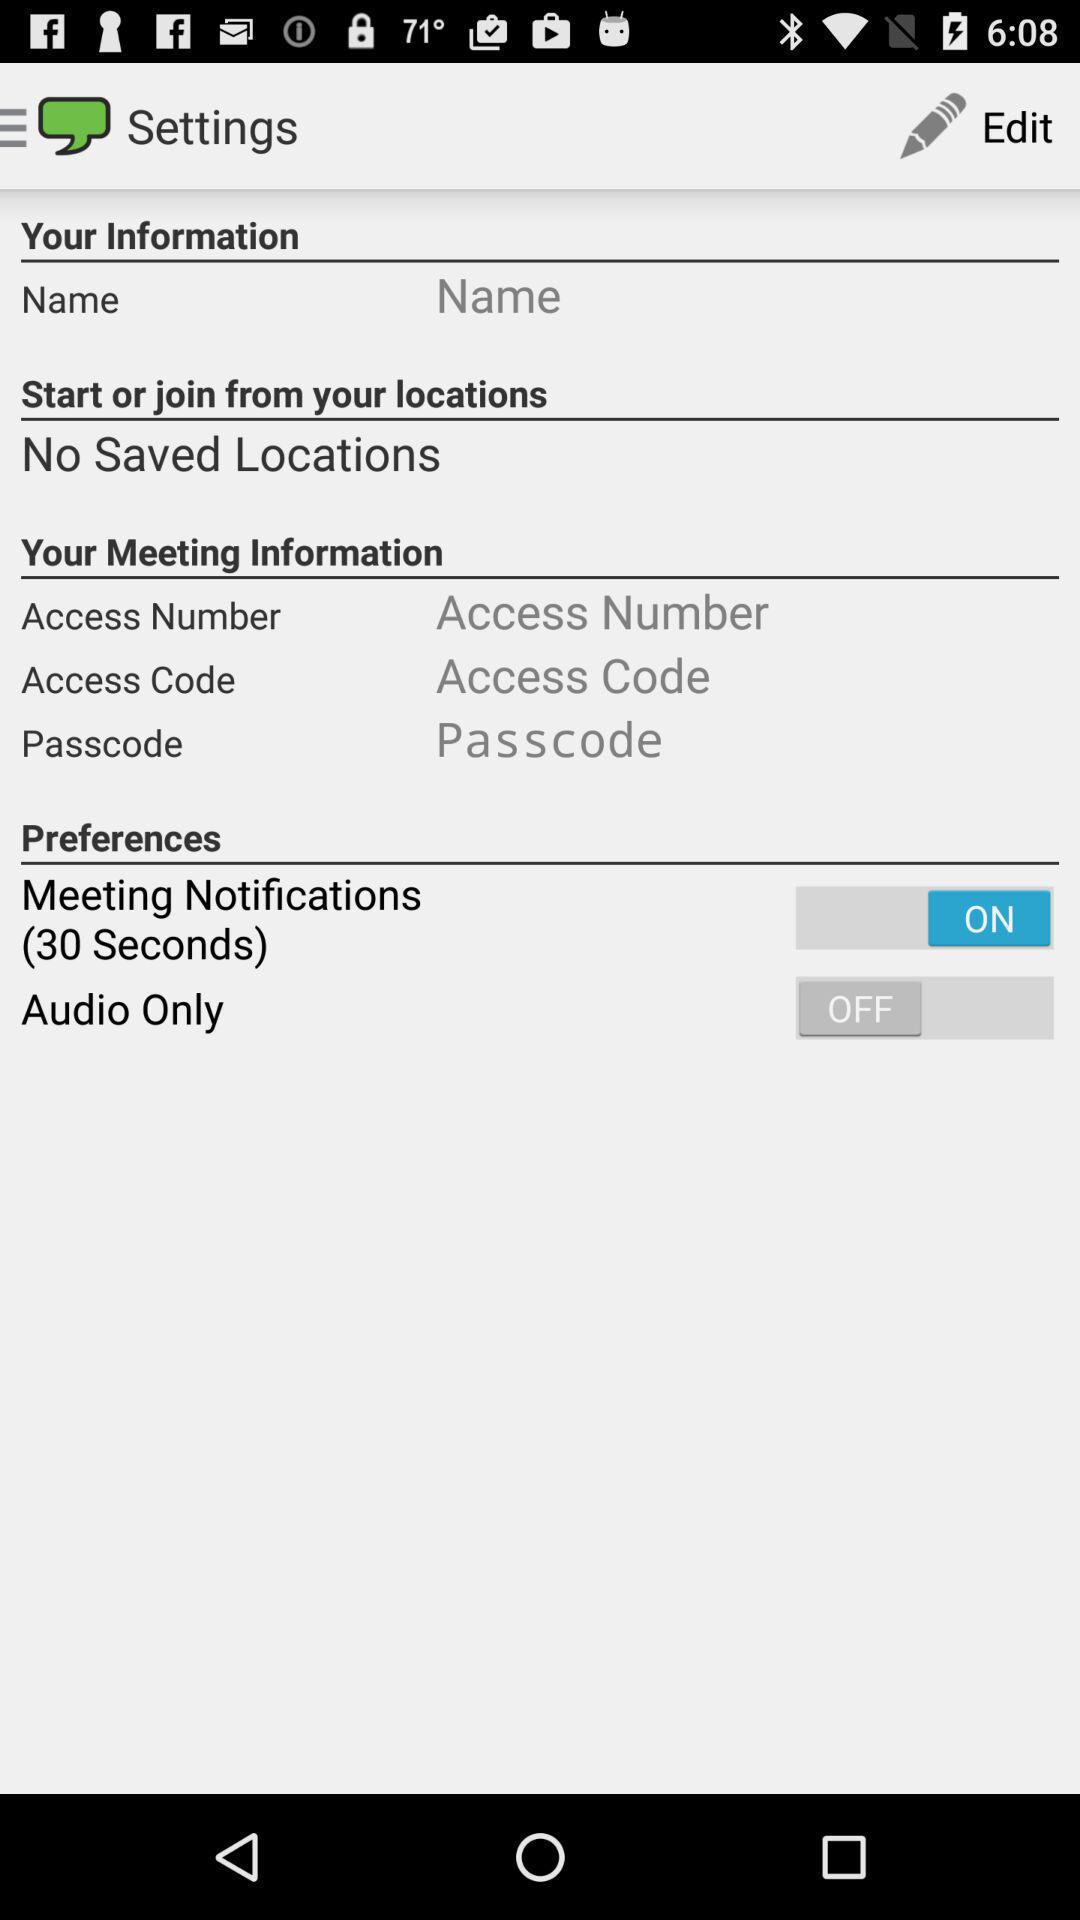What is the status of "Meeting Notifications"? The status of "Meeting Notifications" is "on". 